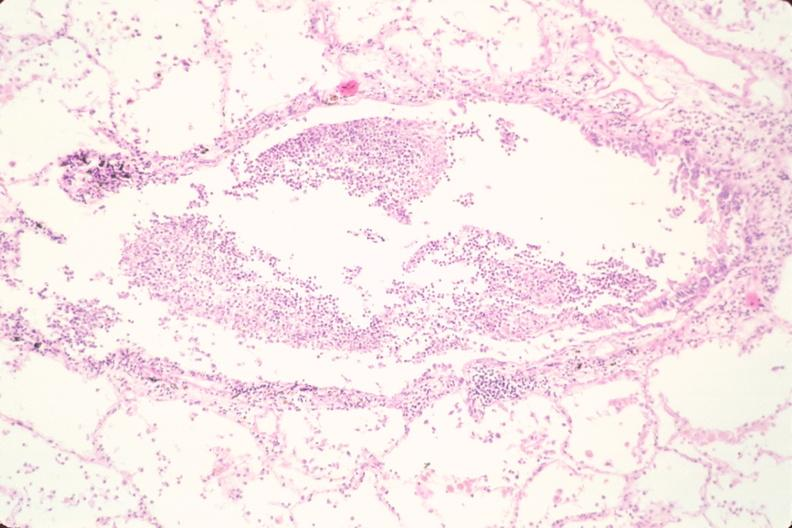s respiratory present?
Answer the question using a single word or phrase. Yes 